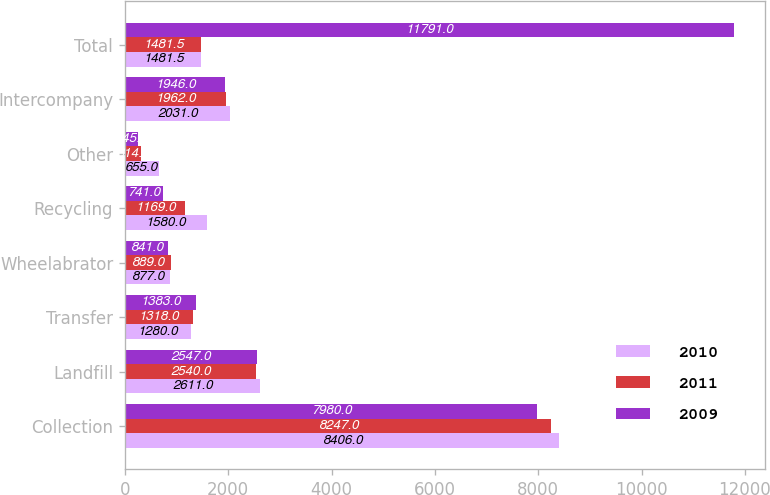<chart> <loc_0><loc_0><loc_500><loc_500><stacked_bar_chart><ecel><fcel>Collection<fcel>Landfill<fcel>Transfer<fcel>Wheelabrator<fcel>Recycling<fcel>Other<fcel>Intercompany<fcel>Total<nl><fcel>2010<fcel>8406<fcel>2611<fcel>1280<fcel>877<fcel>1580<fcel>655<fcel>2031<fcel>1481.5<nl><fcel>2011<fcel>8247<fcel>2540<fcel>1318<fcel>889<fcel>1169<fcel>314<fcel>1962<fcel>1481.5<nl><fcel>2009<fcel>7980<fcel>2547<fcel>1383<fcel>841<fcel>741<fcel>245<fcel>1946<fcel>11791<nl></chart> 